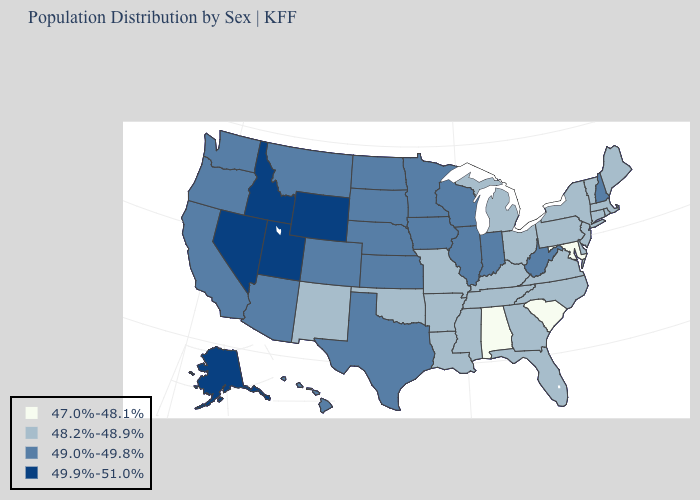What is the highest value in the USA?
Quick response, please. 49.9%-51.0%. Name the states that have a value in the range 49.0%-49.8%?
Concise answer only. Arizona, California, Colorado, Hawaii, Illinois, Indiana, Iowa, Kansas, Minnesota, Montana, Nebraska, New Hampshire, North Dakota, Oregon, South Dakota, Texas, Washington, West Virginia, Wisconsin. What is the value of New Jersey?
Concise answer only. 48.2%-48.9%. Among the states that border Colorado , does Wyoming have the highest value?
Keep it brief. Yes. Does the first symbol in the legend represent the smallest category?
Keep it brief. Yes. Does the first symbol in the legend represent the smallest category?
Answer briefly. Yes. What is the highest value in the Northeast ?
Keep it brief. 49.0%-49.8%. What is the value of Virginia?
Keep it brief. 48.2%-48.9%. Does the map have missing data?
Answer briefly. No. Name the states that have a value in the range 47.0%-48.1%?
Write a very short answer. Alabama, Maryland, South Carolina. Among the states that border Ohio , does Kentucky have the lowest value?
Be succinct. Yes. Does the map have missing data?
Keep it brief. No. What is the value of Louisiana?
Quick response, please. 48.2%-48.9%. Is the legend a continuous bar?
Quick response, please. No. Among the states that border South Carolina , which have the highest value?
Keep it brief. Georgia, North Carolina. 